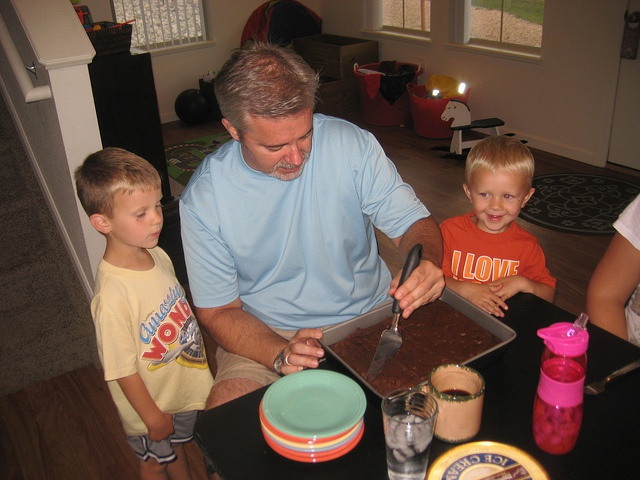Describe the objects in this image and their specific colors. I can see people in black, darkgray, brown, and lightblue tones, dining table in black, maroon, darkgray, and gray tones, people in black, tan, and maroon tones, people in black, brown, salmon, and maroon tones, and dining table in black, maroon, and brown tones in this image. 